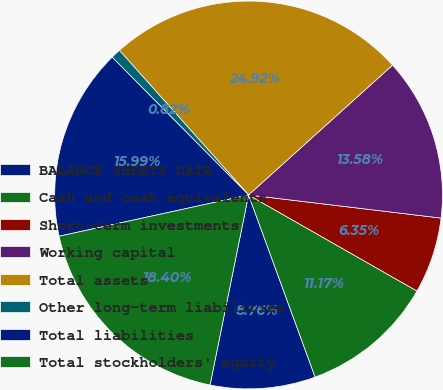Convert chart. <chart><loc_0><loc_0><loc_500><loc_500><pie_chart><fcel>BALANCE SHEETS DATA<fcel>Cash and cash equivalents<fcel>Short-term investments<fcel>Working capital<fcel>Total assets<fcel>Other long-term liabilities<fcel>Total liabilities<fcel>Total stockholders' equity<nl><fcel>8.76%<fcel>11.17%<fcel>6.35%<fcel>13.58%<fcel>24.92%<fcel>0.82%<fcel>15.99%<fcel>18.4%<nl></chart> 